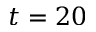Convert formula to latex. <formula><loc_0><loc_0><loc_500><loc_500>t = 2 0</formula> 